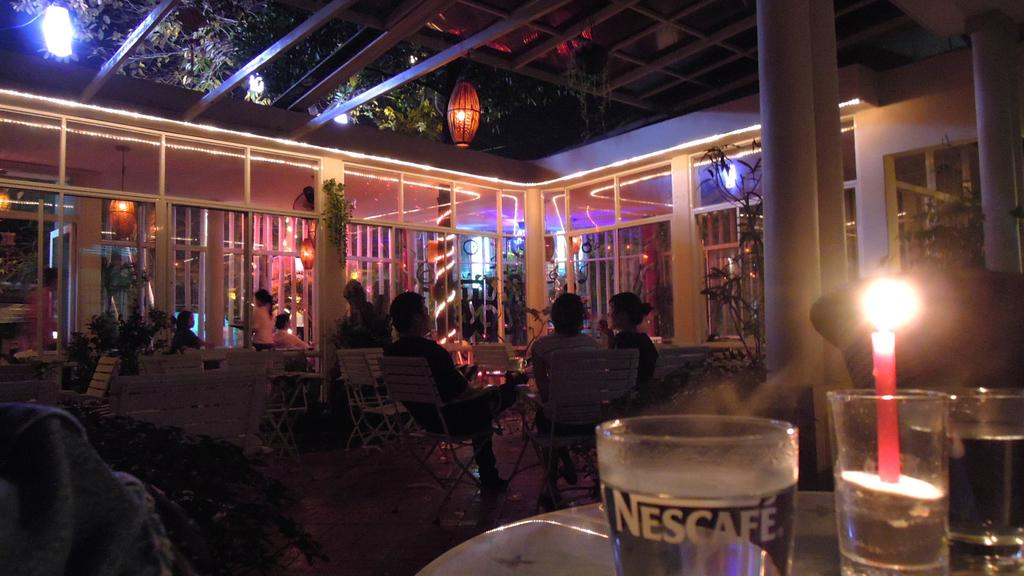Provide a one-sentence caption for the provided image. a shot of a crowded bar or cafe with a glass reading Nescafe near the front. 